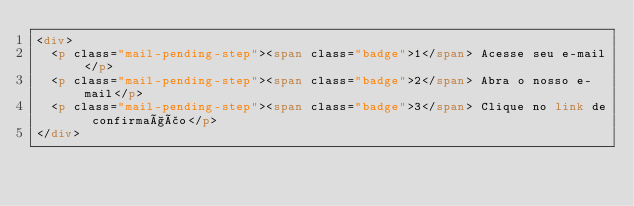<code> <loc_0><loc_0><loc_500><loc_500><_HTML_><div>
  <p class="mail-pending-step"><span class="badge">1</span> Acesse seu e-mail</p>
  <p class="mail-pending-step"><span class="badge">2</span> Abra o nosso e-mail</p>
  <p class="mail-pending-step"><span class="badge">3</span> Clique no link de confirmação</p>
</div>
</code> 